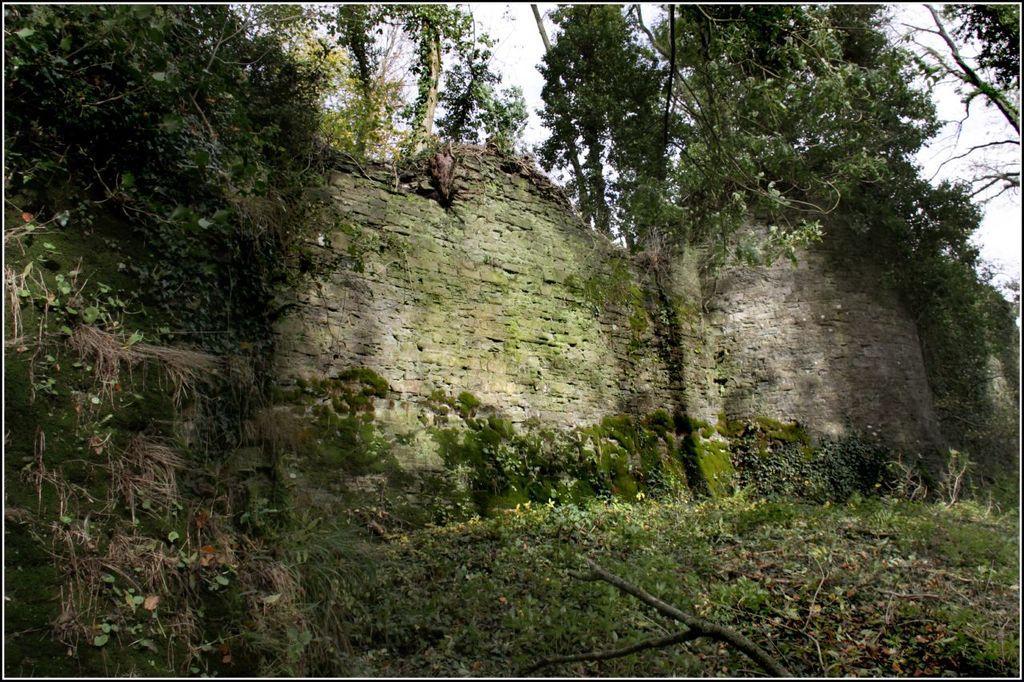Describe this image in one or two sentences. In this picture we can see few plants, trees and walls. 